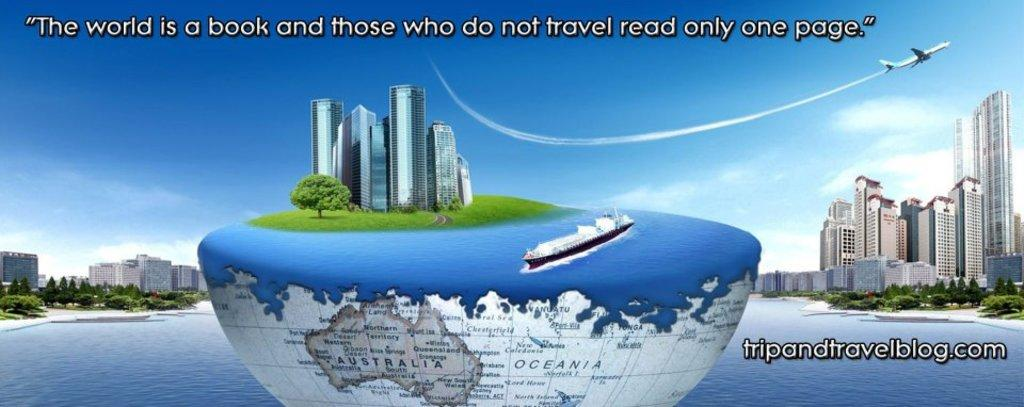Provide a one-sentence caption for the provided image. Half a globe has Australia visible on the bottom and a cruise ship on top. 